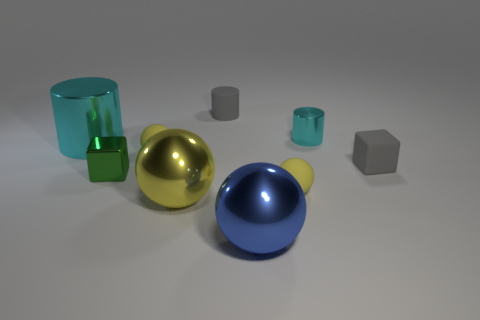Subtract all cyan cylinders. How many yellow spheres are left? 3 Subtract 1 balls. How many balls are left? 3 Subtract all gray spheres. Subtract all cyan cubes. How many spheres are left? 4 Add 1 large red metal cubes. How many objects exist? 10 Subtract all cylinders. How many objects are left? 6 Add 3 blue balls. How many blue balls are left? 4 Add 7 big cyan shiny cylinders. How many big cyan shiny cylinders exist? 8 Subtract 0 red cylinders. How many objects are left? 9 Subtract all big cyan objects. Subtract all large metallic balls. How many objects are left? 6 